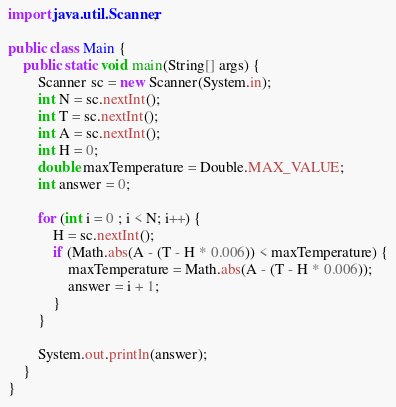<code> <loc_0><loc_0><loc_500><loc_500><_Java_>import java.util.Scanner;

public class Main {
	public static void main(String[] args) {
		Scanner sc = new Scanner(System.in);
		int N = sc.nextInt();
		int T = sc.nextInt();
		int A = sc.nextInt();
		int H = 0;
		double maxTemperature = Double.MAX_VALUE;
		int answer = 0;

		for (int i = 0 ; i < N; i++) {
			H = sc.nextInt();
			if (Math.abs(A - (T - H * 0.006)) < maxTemperature) {
				maxTemperature = Math.abs(A - (T - H * 0.006));
				answer = i + 1;
			}
		}

		System.out.println(answer);
	}
}
</code> 